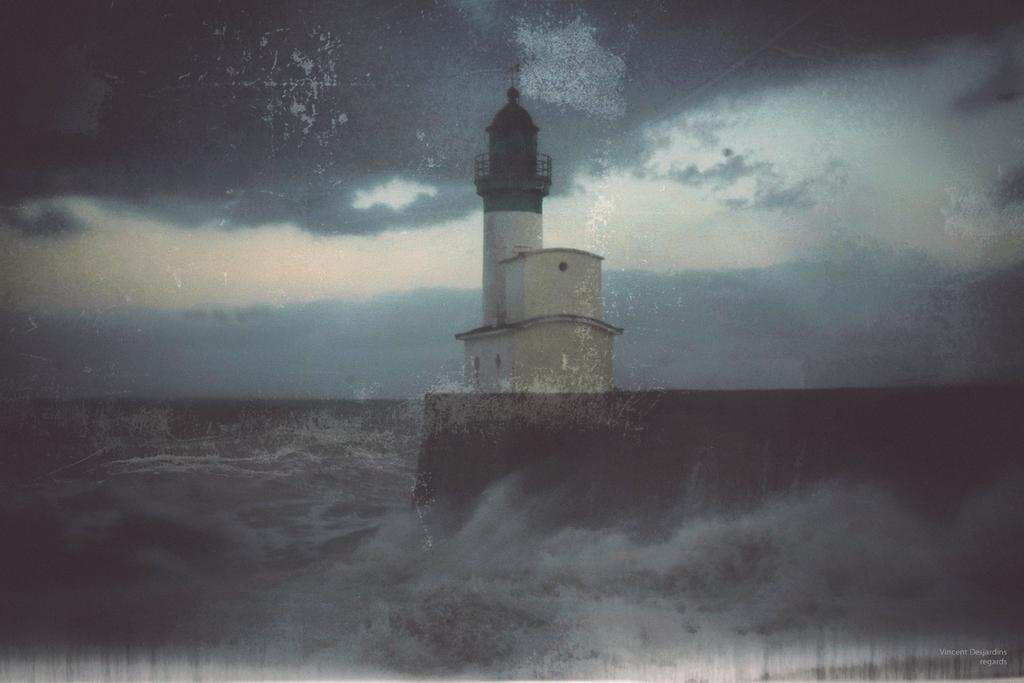How would you summarize this image in a sentence or two? This is an edited image. At the bottom, I can see the water. It seems to be an ocean. In the middle of the image there is a tower. At top of the image I can see the sky and clouds. 